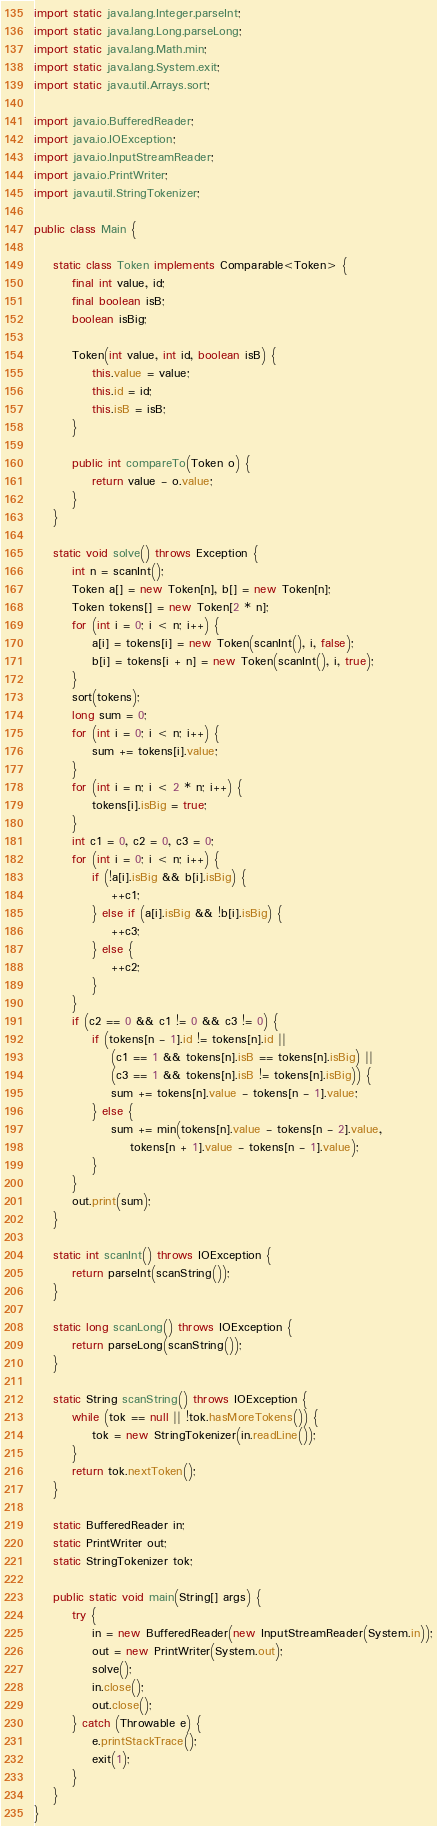Convert code to text. <code><loc_0><loc_0><loc_500><loc_500><_Java_>import static java.lang.Integer.parseInt;
import static java.lang.Long.parseLong;
import static java.lang.Math.min;
import static java.lang.System.exit;
import static java.util.Arrays.sort;

import java.io.BufferedReader;
import java.io.IOException;
import java.io.InputStreamReader;
import java.io.PrintWriter;
import java.util.StringTokenizer;

public class Main {

	static class Token implements Comparable<Token> {
		final int value, id;
		final boolean isB;
		boolean isBig;

		Token(int value, int id, boolean isB) {
			this.value = value;
			this.id = id;
			this.isB = isB;
		}

		public int compareTo(Token o) {
			return value - o.value;
		}
	}

	static void solve() throws Exception {
		int n = scanInt();
		Token a[] = new Token[n], b[] = new Token[n];
		Token tokens[] = new Token[2 * n];
		for (int i = 0; i < n; i++) {
			a[i] = tokens[i] = new Token(scanInt(), i, false);
			b[i] = tokens[i + n] = new Token(scanInt(), i, true);
		}
		sort(tokens);
		long sum = 0;
		for (int i = 0; i < n; i++) {
			sum += tokens[i].value;
		}
		for (int i = n; i < 2 * n; i++) {
			tokens[i].isBig = true;
		}
		int c1 = 0, c2 = 0, c3 = 0;
		for (int i = 0; i < n; i++) {
			if (!a[i].isBig && b[i].isBig) {
				++c1;
			} else if (a[i].isBig && !b[i].isBig) {
				++c3;
			} else {
				++c2;
			}
		}
		if (c2 == 0 && c1 != 0 && c3 != 0) {
			if (tokens[n - 1].id != tokens[n].id ||
				(c1 == 1 && tokens[n].isB == tokens[n].isBig) ||
				(c3 == 1 && tokens[n].isB != tokens[n].isBig)) {
				sum += tokens[n].value - tokens[n - 1].value;
			} else {
				sum += min(tokens[n].value - tokens[n - 2].value,
					tokens[n + 1].value - tokens[n - 1].value);
			}
		}
		out.print(sum);
	}

	static int scanInt() throws IOException {
		return parseInt(scanString());
	}

	static long scanLong() throws IOException {
		return parseLong(scanString());
	}

	static String scanString() throws IOException {
		while (tok == null || !tok.hasMoreTokens()) {
			tok = new StringTokenizer(in.readLine());
		}
		return tok.nextToken();
	}

	static BufferedReader in;
	static PrintWriter out;
	static StringTokenizer tok;

	public static void main(String[] args) {
		try {
			in = new BufferedReader(new InputStreamReader(System.in));
			out = new PrintWriter(System.out);
			solve();
			in.close();
			out.close();
		} catch (Throwable e) {
			e.printStackTrace();
			exit(1);
		}
	}
}</code> 